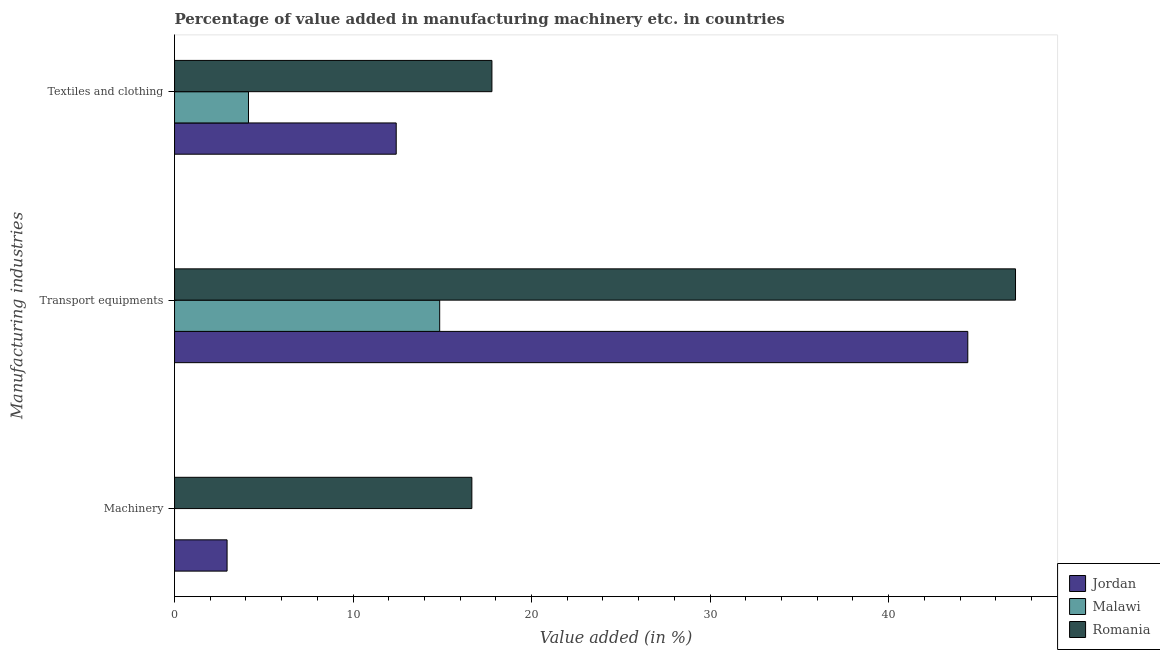How many groups of bars are there?
Ensure brevity in your answer.  3. How many bars are there on the 3rd tick from the top?
Offer a very short reply. 2. What is the label of the 1st group of bars from the top?
Your response must be concise. Textiles and clothing. What is the value added in manufacturing machinery in Malawi?
Ensure brevity in your answer.  0. Across all countries, what is the maximum value added in manufacturing machinery?
Provide a short and direct response. 16.65. Across all countries, what is the minimum value added in manufacturing transport equipments?
Your answer should be compact. 14.85. In which country was the value added in manufacturing transport equipments maximum?
Offer a terse response. Romania. What is the total value added in manufacturing machinery in the graph?
Offer a very short reply. 19.6. What is the difference between the value added in manufacturing textile and clothing in Malawi and that in Jordan?
Ensure brevity in your answer.  -8.28. What is the difference between the value added in manufacturing machinery in Jordan and the value added in manufacturing transport equipments in Malawi?
Your response must be concise. -11.91. What is the average value added in manufacturing textile and clothing per country?
Keep it short and to the point. 11.45. What is the difference between the value added in manufacturing textile and clothing and value added in manufacturing transport equipments in Malawi?
Provide a succinct answer. -10.71. What is the ratio of the value added in manufacturing transport equipments in Romania to that in Jordan?
Ensure brevity in your answer.  1.06. What is the difference between the highest and the second highest value added in manufacturing textile and clothing?
Offer a terse response. 5.36. What is the difference between the highest and the lowest value added in manufacturing textile and clothing?
Your response must be concise. 13.64. In how many countries, is the value added in manufacturing machinery greater than the average value added in manufacturing machinery taken over all countries?
Your response must be concise. 1. Is it the case that in every country, the sum of the value added in manufacturing machinery and value added in manufacturing transport equipments is greater than the value added in manufacturing textile and clothing?
Give a very brief answer. Yes. How many bars are there?
Provide a short and direct response. 8. Are all the bars in the graph horizontal?
Your answer should be compact. Yes. How many countries are there in the graph?
Provide a short and direct response. 3. Are the values on the major ticks of X-axis written in scientific E-notation?
Provide a succinct answer. No. Does the graph contain any zero values?
Your response must be concise. Yes. How many legend labels are there?
Make the answer very short. 3. How are the legend labels stacked?
Make the answer very short. Vertical. What is the title of the graph?
Your answer should be compact. Percentage of value added in manufacturing machinery etc. in countries. What is the label or title of the X-axis?
Your response must be concise. Value added (in %). What is the label or title of the Y-axis?
Offer a very short reply. Manufacturing industries. What is the Value added (in %) in Jordan in Machinery?
Provide a succinct answer. 2.94. What is the Value added (in %) in Romania in Machinery?
Give a very brief answer. 16.65. What is the Value added (in %) of Jordan in Transport equipments?
Offer a very short reply. 44.44. What is the Value added (in %) in Malawi in Transport equipments?
Give a very brief answer. 14.85. What is the Value added (in %) in Romania in Transport equipments?
Keep it short and to the point. 47.11. What is the Value added (in %) of Jordan in Textiles and clothing?
Give a very brief answer. 12.42. What is the Value added (in %) of Malawi in Textiles and clothing?
Provide a short and direct response. 4.14. What is the Value added (in %) in Romania in Textiles and clothing?
Ensure brevity in your answer.  17.78. Across all Manufacturing industries, what is the maximum Value added (in %) of Jordan?
Offer a very short reply. 44.44. Across all Manufacturing industries, what is the maximum Value added (in %) in Malawi?
Offer a terse response. 14.85. Across all Manufacturing industries, what is the maximum Value added (in %) in Romania?
Offer a terse response. 47.11. Across all Manufacturing industries, what is the minimum Value added (in %) in Jordan?
Offer a terse response. 2.94. Across all Manufacturing industries, what is the minimum Value added (in %) of Romania?
Offer a terse response. 16.65. What is the total Value added (in %) in Jordan in the graph?
Offer a very short reply. 59.8. What is the total Value added (in %) of Malawi in the graph?
Provide a succinct answer. 18.99. What is the total Value added (in %) in Romania in the graph?
Provide a succinct answer. 81.54. What is the difference between the Value added (in %) in Jordan in Machinery and that in Transport equipments?
Give a very brief answer. -41.49. What is the difference between the Value added (in %) in Romania in Machinery and that in Transport equipments?
Provide a succinct answer. -30.45. What is the difference between the Value added (in %) of Jordan in Machinery and that in Textiles and clothing?
Your response must be concise. -9.47. What is the difference between the Value added (in %) of Romania in Machinery and that in Textiles and clothing?
Your answer should be very brief. -1.12. What is the difference between the Value added (in %) in Jordan in Transport equipments and that in Textiles and clothing?
Ensure brevity in your answer.  32.02. What is the difference between the Value added (in %) in Malawi in Transport equipments and that in Textiles and clothing?
Ensure brevity in your answer.  10.71. What is the difference between the Value added (in %) of Romania in Transport equipments and that in Textiles and clothing?
Your response must be concise. 29.33. What is the difference between the Value added (in %) in Jordan in Machinery and the Value added (in %) in Malawi in Transport equipments?
Your answer should be compact. -11.91. What is the difference between the Value added (in %) of Jordan in Machinery and the Value added (in %) of Romania in Transport equipments?
Your response must be concise. -44.17. What is the difference between the Value added (in %) of Jordan in Machinery and the Value added (in %) of Malawi in Textiles and clothing?
Offer a terse response. -1.2. What is the difference between the Value added (in %) of Jordan in Machinery and the Value added (in %) of Romania in Textiles and clothing?
Offer a very short reply. -14.84. What is the difference between the Value added (in %) in Jordan in Transport equipments and the Value added (in %) in Malawi in Textiles and clothing?
Give a very brief answer. 40.29. What is the difference between the Value added (in %) in Jordan in Transport equipments and the Value added (in %) in Romania in Textiles and clothing?
Offer a very short reply. 26.66. What is the difference between the Value added (in %) of Malawi in Transport equipments and the Value added (in %) of Romania in Textiles and clothing?
Offer a very short reply. -2.93. What is the average Value added (in %) in Jordan per Manufacturing industries?
Your answer should be very brief. 19.93. What is the average Value added (in %) in Malawi per Manufacturing industries?
Provide a short and direct response. 6.33. What is the average Value added (in %) of Romania per Manufacturing industries?
Offer a very short reply. 27.18. What is the difference between the Value added (in %) of Jordan and Value added (in %) of Romania in Machinery?
Provide a short and direct response. -13.71. What is the difference between the Value added (in %) in Jordan and Value added (in %) in Malawi in Transport equipments?
Keep it short and to the point. 29.58. What is the difference between the Value added (in %) in Jordan and Value added (in %) in Romania in Transport equipments?
Your answer should be compact. -2.67. What is the difference between the Value added (in %) in Malawi and Value added (in %) in Romania in Transport equipments?
Provide a short and direct response. -32.26. What is the difference between the Value added (in %) of Jordan and Value added (in %) of Malawi in Textiles and clothing?
Ensure brevity in your answer.  8.28. What is the difference between the Value added (in %) in Jordan and Value added (in %) in Romania in Textiles and clothing?
Offer a terse response. -5.36. What is the difference between the Value added (in %) of Malawi and Value added (in %) of Romania in Textiles and clothing?
Ensure brevity in your answer.  -13.64. What is the ratio of the Value added (in %) of Jordan in Machinery to that in Transport equipments?
Keep it short and to the point. 0.07. What is the ratio of the Value added (in %) of Romania in Machinery to that in Transport equipments?
Offer a very short reply. 0.35. What is the ratio of the Value added (in %) in Jordan in Machinery to that in Textiles and clothing?
Your response must be concise. 0.24. What is the ratio of the Value added (in %) of Romania in Machinery to that in Textiles and clothing?
Give a very brief answer. 0.94. What is the ratio of the Value added (in %) in Jordan in Transport equipments to that in Textiles and clothing?
Keep it short and to the point. 3.58. What is the ratio of the Value added (in %) of Malawi in Transport equipments to that in Textiles and clothing?
Give a very brief answer. 3.59. What is the ratio of the Value added (in %) in Romania in Transport equipments to that in Textiles and clothing?
Provide a succinct answer. 2.65. What is the difference between the highest and the second highest Value added (in %) in Jordan?
Provide a succinct answer. 32.02. What is the difference between the highest and the second highest Value added (in %) in Romania?
Offer a very short reply. 29.33. What is the difference between the highest and the lowest Value added (in %) in Jordan?
Your response must be concise. 41.49. What is the difference between the highest and the lowest Value added (in %) in Malawi?
Your response must be concise. 14.85. What is the difference between the highest and the lowest Value added (in %) of Romania?
Give a very brief answer. 30.45. 